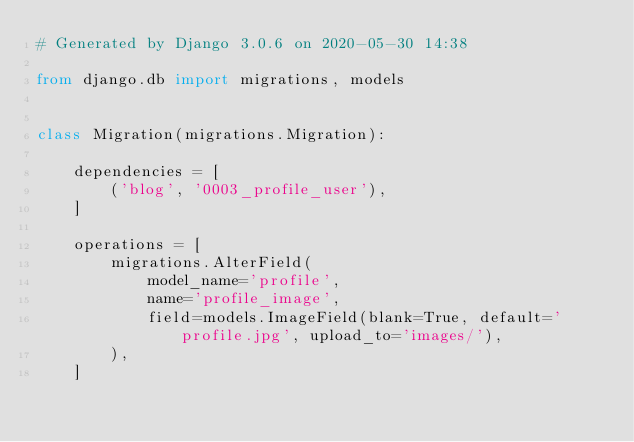Convert code to text. <code><loc_0><loc_0><loc_500><loc_500><_Python_># Generated by Django 3.0.6 on 2020-05-30 14:38

from django.db import migrations, models


class Migration(migrations.Migration):

    dependencies = [
        ('blog', '0003_profile_user'),
    ]

    operations = [
        migrations.AlterField(
            model_name='profile',
            name='profile_image',
            field=models.ImageField(blank=True, default='profile.jpg', upload_to='images/'),
        ),
    ]
</code> 